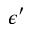Convert formula to latex. <formula><loc_0><loc_0><loc_500><loc_500>\epsilon ^ { \prime }</formula> 